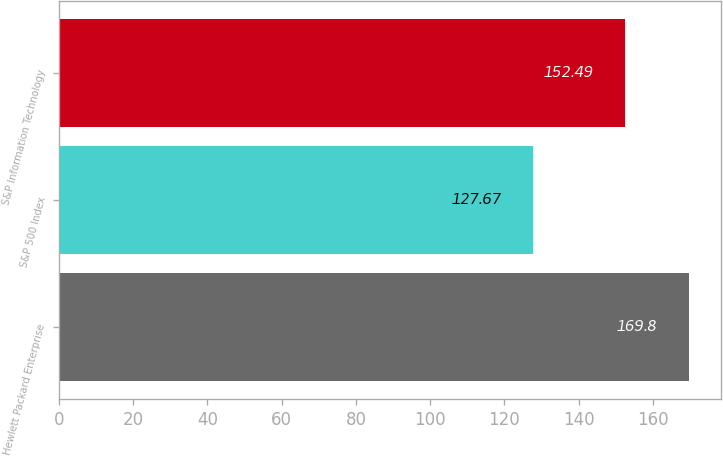Convert chart to OTSL. <chart><loc_0><loc_0><loc_500><loc_500><bar_chart><fcel>Hewlett Packard Enterprise<fcel>S&P 500 Index<fcel>S&P Information Technology<nl><fcel>169.8<fcel>127.67<fcel>152.49<nl></chart> 